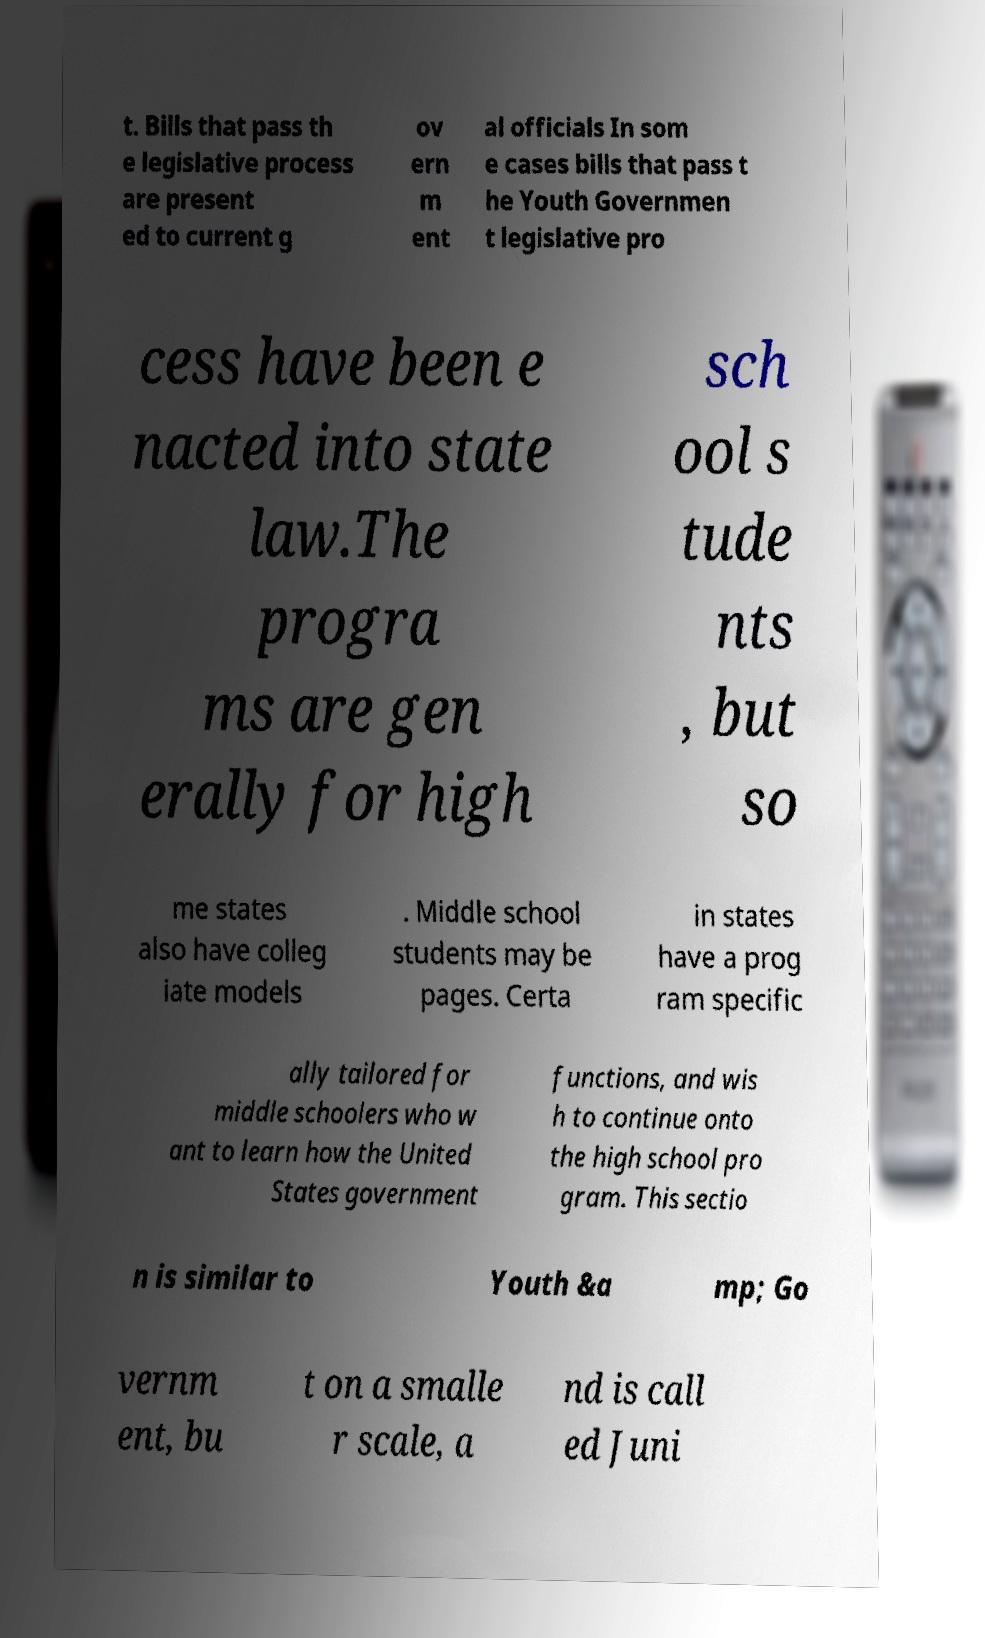I need the written content from this picture converted into text. Can you do that? t. Bills that pass th e legislative process are present ed to current g ov ern m ent al officials In som e cases bills that pass t he Youth Governmen t legislative pro cess have been e nacted into state law.The progra ms are gen erally for high sch ool s tude nts , but so me states also have colleg iate models . Middle school students may be pages. Certa in states have a prog ram specific ally tailored for middle schoolers who w ant to learn how the United States government functions, and wis h to continue onto the high school pro gram. This sectio n is similar to Youth &a mp; Go vernm ent, bu t on a smalle r scale, a nd is call ed Juni 